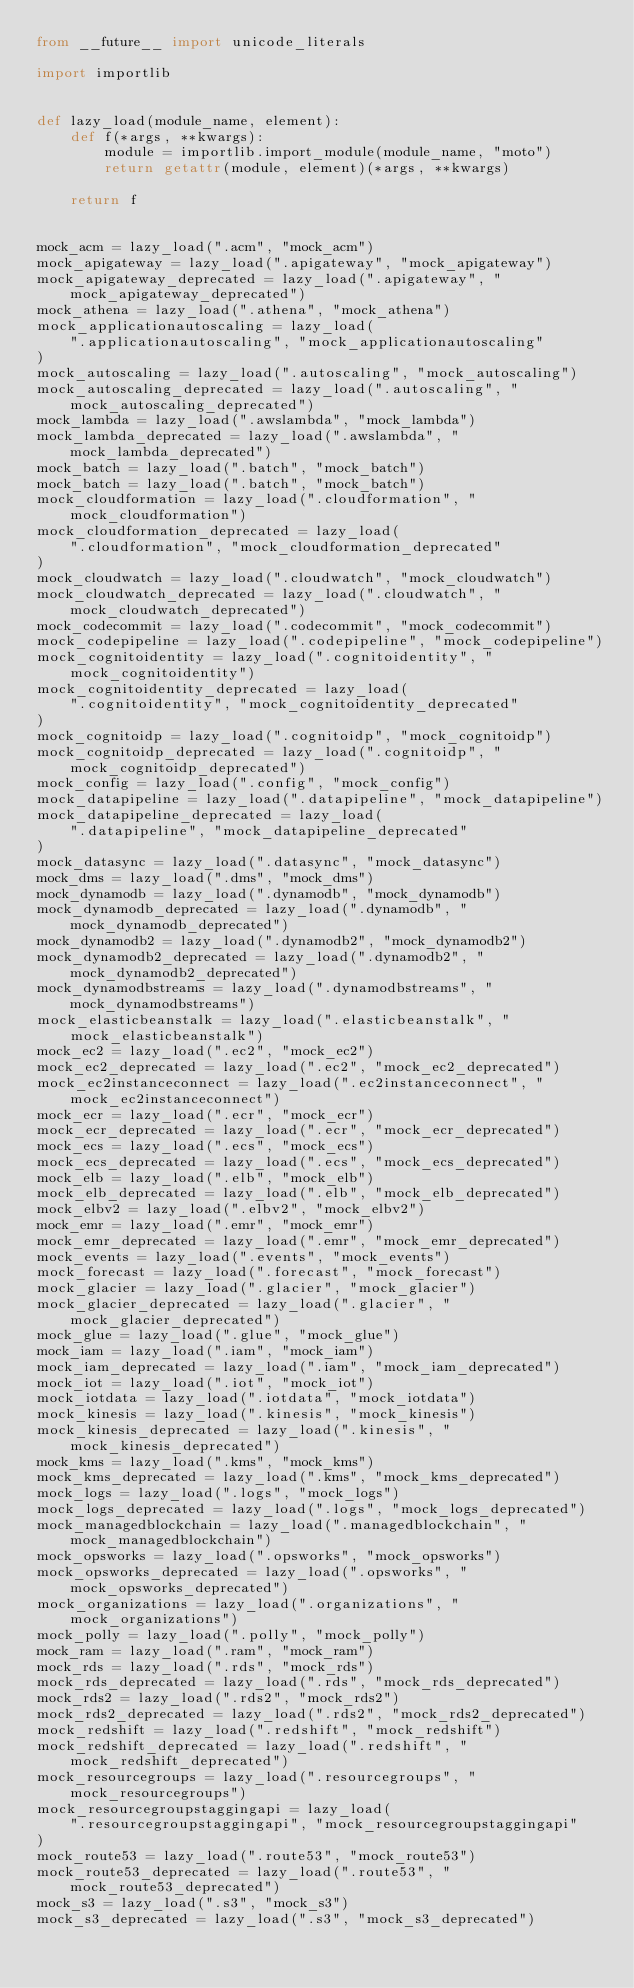<code> <loc_0><loc_0><loc_500><loc_500><_Python_>from __future__ import unicode_literals

import importlib


def lazy_load(module_name, element):
    def f(*args, **kwargs):
        module = importlib.import_module(module_name, "moto")
        return getattr(module, element)(*args, **kwargs)

    return f


mock_acm = lazy_load(".acm", "mock_acm")
mock_apigateway = lazy_load(".apigateway", "mock_apigateway")
mock_apigateway_deprecated = lazy_load(".apigateway", "mock_apigateway_deprecated")
mock_athena = lazy_load(".athena", "mock_athena")
mock_applicationautoscaling = lazy_load(
    ".applicationautoscaling", "mock_applicationautoscaling"
)
mock_autoscaling = lazy_load(".autoscaling", "mock_autoscaling")
mock_autoscaling_deprecated = lazy_load(".autoscaling", "mock_autoscaling_deprecated")
mock_lambda = lazy_load(".awslambda", "mock_lambda")
mock_lambda_deprecated = lazy_load(".awslambda", "mock_lambda_deprecated")
mock_batch = lazy_load(".batch", "mock_batch")
mock_batch = lazy_load(".batch", "mock_batch")
mock_cloudformation = lazy_load(".cloudformation", "mock_cloudformation")
mock_cloudformation_deprecated = lazy_load(
    ".cloudformation", "mock_cloudformation_deprecated"
)
mock_cloudwatch = lazy_load(".cloudwatch", "mock_cloudwatch")
mock_cloudwatch_deprecated = lazy_load(".cloudwatch", "mock_cloudwatch_deprecated")
mock_codecommit = lazy_load(".codecommit", "mock_codecommit")
mock_codepipeline = lazy_load(".codepipeline", "mock_codepipeline")
mock_cognitoidentity = lazy_load(".cognitoidentity", "mock_cognitoidentity")
mock_cognitoidentity_deprecated = lazy_load(
    ".cognitoidentity", "mock_cognitoidentity_deprecated"
)
mock_cognitoidp = lazy_load(".cognitoidp", "mock_cognitoidp")
mock_cognitoidp_deprecated = lazy_load(".cognitoidp", "mock_cognitoidp_deprecated")
mock_config = lazy_load(".config", "mock_config")
mock_datapipeline = lazy_load(".datapipeline", "mock_datapipeline")
mock_datapipeline_deprecated = lazy_load(
    ".datapipeline", "mock_datapipeline_deprecated"
)
mock_datasync = lazy_load(".datasync", "mock_datasync")
mock_dms = lazy_load(".dms", "mock_dms")
mock_dynamodb = lazy_load(".dynamodb", "mock_dynamodb")
mock_dynamodb_deprecated = lazy_load(".dynamodb", "mock_dynamodb_deprecated")
mock_dynamodb2 = lazy_load(".dynamodb2", "mock_dynamodb2")
mock_dynamodb2_deprecated = lazy_load(".dynamodb2", "mock_dynamodb2_deprecated")
mock_dynamodbstreams = lazy_load(".dynamodbstreams", "mock_dynamodbstreams")
mock_elasticbeanstalk = lazy_load(".elasticbeanstalk", "mock_elasticbeanstalk")
mock_ec2 = lazy_load(".ec2", "mock_ec2")
mock_ec2_deprecated = lazy_load(".ec2", "mock_ec2_deprecated")
mock_ec2instanceconnect = lazy_load(".ec2instanceconnect", "mock_ec2instanceconnect")
mock_ecr = lazy_load(".ecr", "mock_ecr")
mock_ecr_deprecated = lazy_load(".ecr", "mock_ecr_deprecated")
mock_ecs = lazy_load(".ecs", "mock_ecs")
mock_ecs_deprecated = lazy_load(".ecs", "mock_ecs_deprecated")
mock_elb = lazy_load(".elb", "mock_elb")
mock_elb_deprecated = lazy_load(".elb", "mock_elb_deprecated")
mock_elbv2 = lazy_load(".elbv2", "mock_elbv2")
mock_emr = lazy_load(".emr", "mock_emr")
mock_emr_deprecated = lazy_load(".emr", "mock_emr_deprecated")
mock_events = lazy_load(".events", "mock_events")
mock_forecast = lazy_load(".forecast", "mock_forecast")
mock_glacier = lazy_load(".glacier", "mock_glacier")
mock_glacier_deprecated = lazy_load(".glacier", "mock_glacier_deprecated")
mock_glue = lazy_load(".glue", "mock_glue")
mock_iam = lazy_load(".iam", "mock_iam")
mock_iam_deprecated = lazy_load(".iam", "mock_iam_deprecated")
mock_iot = lazy_load(".iot", "mock_iot")
mock_iotdata = lazy_load(".iotdata", "mock_iotdata")
mock_kinesis = lazy_load(".kinesis", "mock_kinesis")
mock_kinesis_deprecated = lazy_load(".kinesis", "mock_kinesis_deprecated")
mock_kms = lazy_load(".kms", "mock_kms")
mock_kms_deprecated = lazy_load(".kms", "mock_kms_deprecated")
mock_logs = lazy_load(".logs", "mock_logs")
mock_logs_deprecated = lazy_load(".logs", "mock_logs_deprecated")
mock_managedblockchain = lazy_load(".managedblockchain", "mock_managedblockchain")
mock_opsworks = lazy_load(".opsworks", "mock_opsworks")
mock_opsworks_deprecated = lazy_load(".opsworks", "mock_opsworks_deprecated")
mock_organizations = lazy_load(".organizations", "mock_organizations")
mock_polly = lazy_load(".polly", "mock_polly")
mock_ram = lazy_load(".ram", "mock_ram")
mock_rds = lazy_load(".rds", "mock_rds")
mock_rds_deprecated = lazy_load(".rds", "mock_rds_deprecated")
mock_rds2 = lazy_load(".rds2", "mock_rds2")
mock_rds2_deprecated = lazy_load(".rds2", "mock_rds2_deprecated")
mock_redshift = lazy_load(".redshift", "mock_redshift")
mock_redshift_deprecated = lazy_load(".redshift", "mock_redshift_deprecated")
mock_resourcegroups = lazy_load(".resourcegroups", "mock_resourcegroups")
mock_resourcegroupstaggingapi = lazy_load(
    ".resourcegroupstaggingapi", "mock_resourcegroupstaggingapi"
)
mock_route53 = lazy_load(".route53", "mock_route53")
mock_route53_deprecated = lazy_load(".route53", "mock_route53_deprecated")
mock_s3 = lazy_load(".s3", "mock_s3")
mock_s3_deprecated = lazy_load(".s3", "mock_s3_deprecated")</code> 